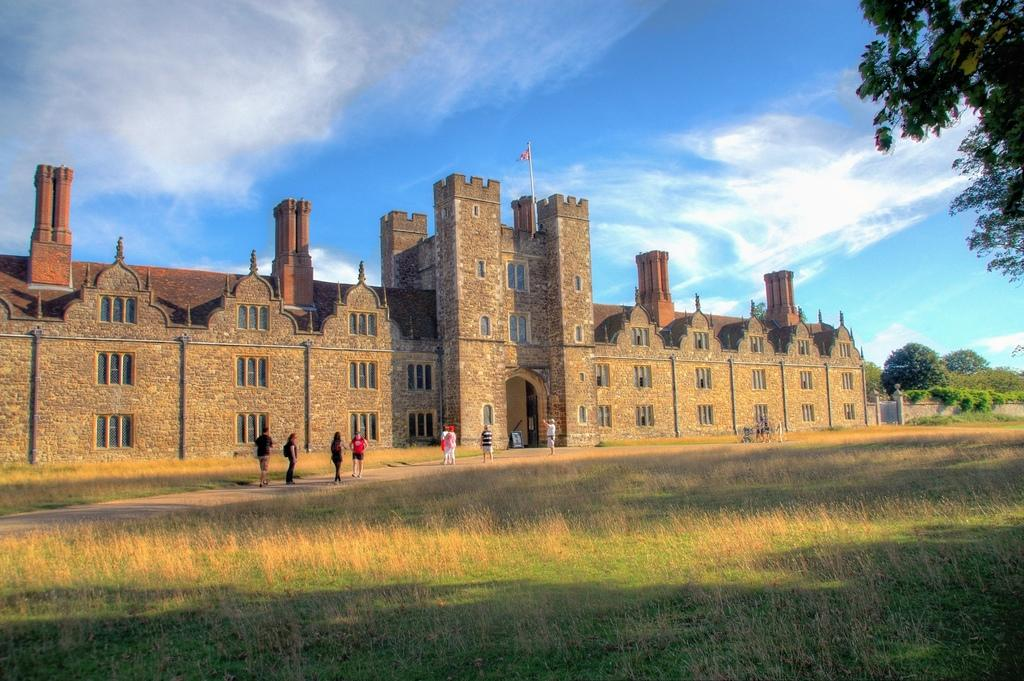What is the main subject of the painting? The main subject of the painting is a building. Are there any people in the painting? Yes, there are people in front of the building. What is on top of the building? There is a flag on top of the building. What can be seen on the right side of the painting? There are trees on the right side of the painting. How would you describe the sky in the painting? The sky is cloudy in the painting. What type of music can be heard coming from the building in the painting? There is no indication of music or any sounds in the painting, so it's not possible to determine what, if any, music might be heard. 